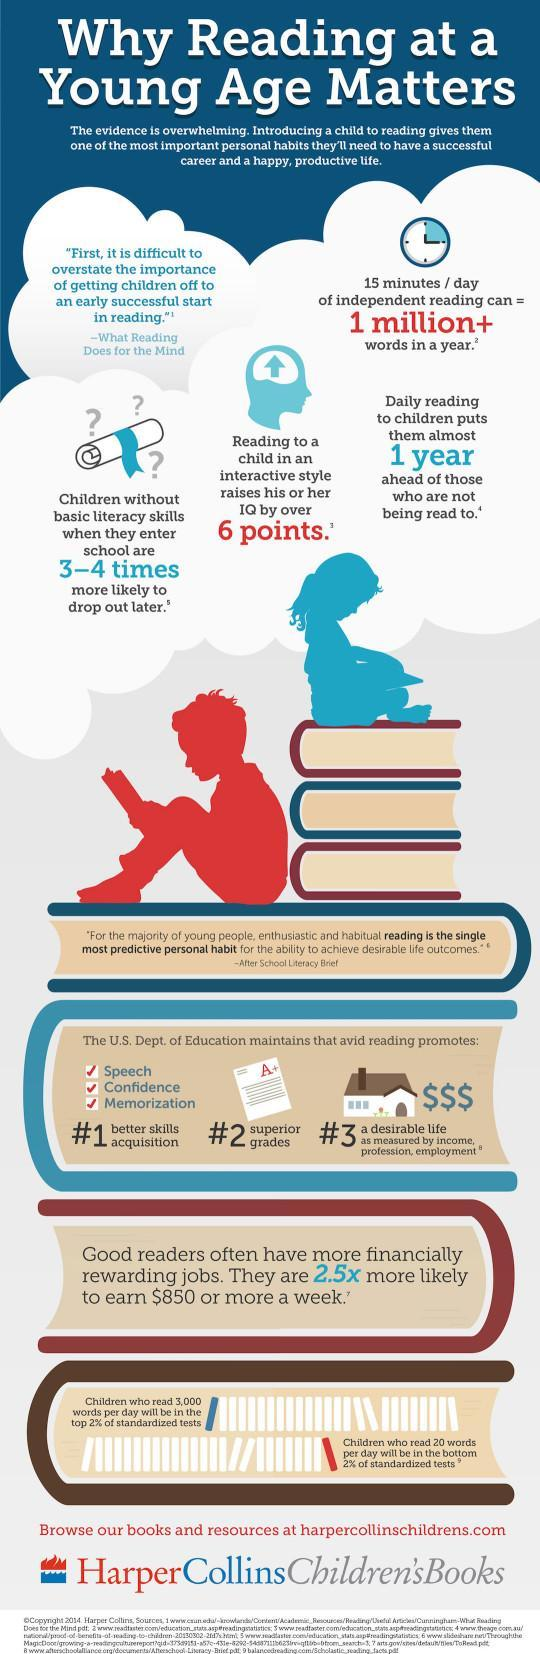What is the colour of the icon of the boy shown- red or blue?
Answer the question with a short phrase. red 